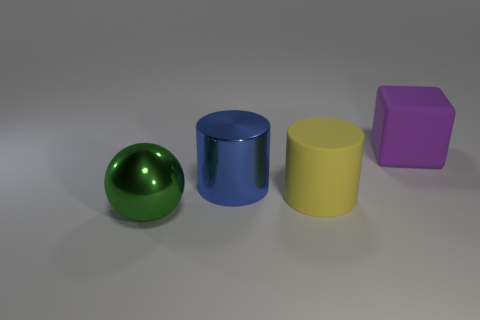Can you tell me the colors of the objects starting from the left? From left to right, the objects' colors are green, blue, yellow, and purple. 